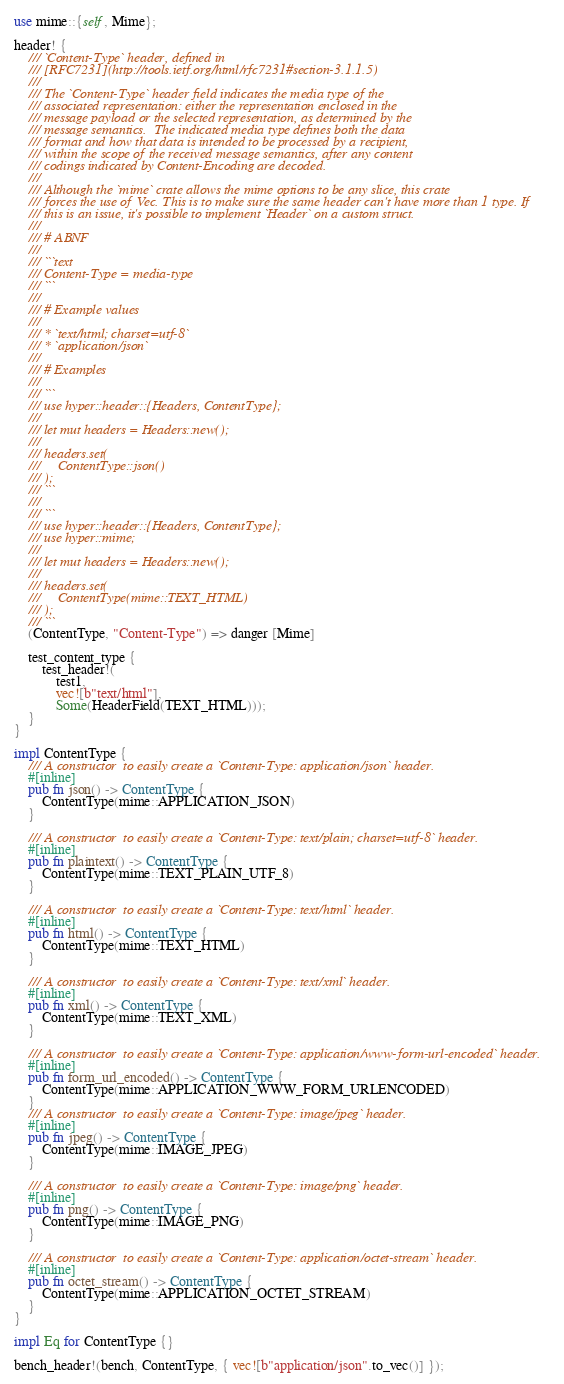<code> <loc_0><loc_0><loc_500><loc_500><_Rust_>use mime::{self, Mime};

header! {
    /// `Content-Type` header, defined in
    /// [RFC7231](http://tools.ietf.org/html/rfc7231#section-3.1.1.5)
    ///
    /// The `Content-Type` header field indicates the media type of the
    /// associated representation: either the representation enclosed in the
    /// message payload or the selected representation, as determined by the
    /// message semantics.  The indicated media type defines both the data
    /// format and how that data is intended to be processed by a recipient,
    /// within the scope of the received message semantics, after any content
    /// codings indicated by Content-Encoding are decoded.
    ///
    /// Although the `mime` crate allows the mime options to be any slice, this crate
    /// forces the use of Vec. This is to make sure the same header can't have more than 1 type. If
    /// this is an issue, it's possible to implement `Header` on a custom struct.
    ///
    /// # ABNF
    ///
    /// ```text
    /// Content-Type = media-type
    /// ```
    ///
    /// # Example values
    ///
    /// * `text/html; charset=utf-8`
    /// * `application/json`
    ///
    /// # Examples
    ///
    /// ```
    /// use hyper::header::{Headers, ContentType};
    ///
    /// let mut headers = Headers::new();
    ///
    /// headers.set(
    ///     ContentType::json()
    /// );
    /// ```
    ///
    /// ```
    /// use hyper::header::{Headers, ContentType};
    /// use hyper::mime;
    ///
    /// let mut headers = Headers::new();
    ///
    /// headers.set(
    ///     ContentType(mime::TEXT_HTML)
    /// );
    /// ```
    (ContentType, "Content-Type") => danger [Mime]

    test_content_type {
        test_header!(
            test1,
            vec![b"text/html"],
            Some(HeaderField(TEXT_HTML)));
    }
}

impl ContentType {
    /// A constructor  to easily create a `Content-Type: application/json` header.
    #[inline]
    pub fn json() -> ContentType {
        ContentType(mime::APPLICATION_JSON)
    }

    /// A constructor  to easily create a `Content-Type: text/plain; charset=utf-8` header.
    #[inline]
    pub fn plaintext() -> ContentType {
        ContentType(mime::TEXT_PLAIN_UTF_8)
    }

    /// A constructor  to easily create a `Content-Type: text/html` header.
    #[inline]
    pub fn html() -> ContentType {
        ContentType(mime::TEXT_HTML)
    }

    /// A constructor  to easily create a `Content-Type: text/xml` header.
    #[inline]
    pub fn xml() -> ContentType {
        ContentType(mime::TEXT_XML)
    }

    /// A constructor  to easily create a `Content-Type: application/www-form-url-encoded` header.
    #[inline]
    pub fn form_url_encoded() -> ContentType {
        ContentType(mime::APPLICATION_WWW_FORM_URLENCODED)
    }
    /// A constructor  to easily create a `Content-Type: image/jpeg` header.
    #[inline]
    pub fn jpeg() -> ContentType {
        ContentType(mime::IMAGE_JPEG)
    }

    /// A constructor  to easily create a `Content-Type: image/png` header.
    #[inline]
    pub fn png() -> ContentType {
        ContentType(mime::IMAGE_PNG)
    }

    /// A constructor  to easily create a `Content-Type: application/octet-stream` header.
    #[inline]
    pub fn octet_stream() -> ContentType {
        ContentType(mime::APPLICATION_OCTET_STREAM)
    }
}

impl Eq for ContentType {}

bench_header!(bench, ContentType, { vec![b"application/json".to_vec()] });
</code> 